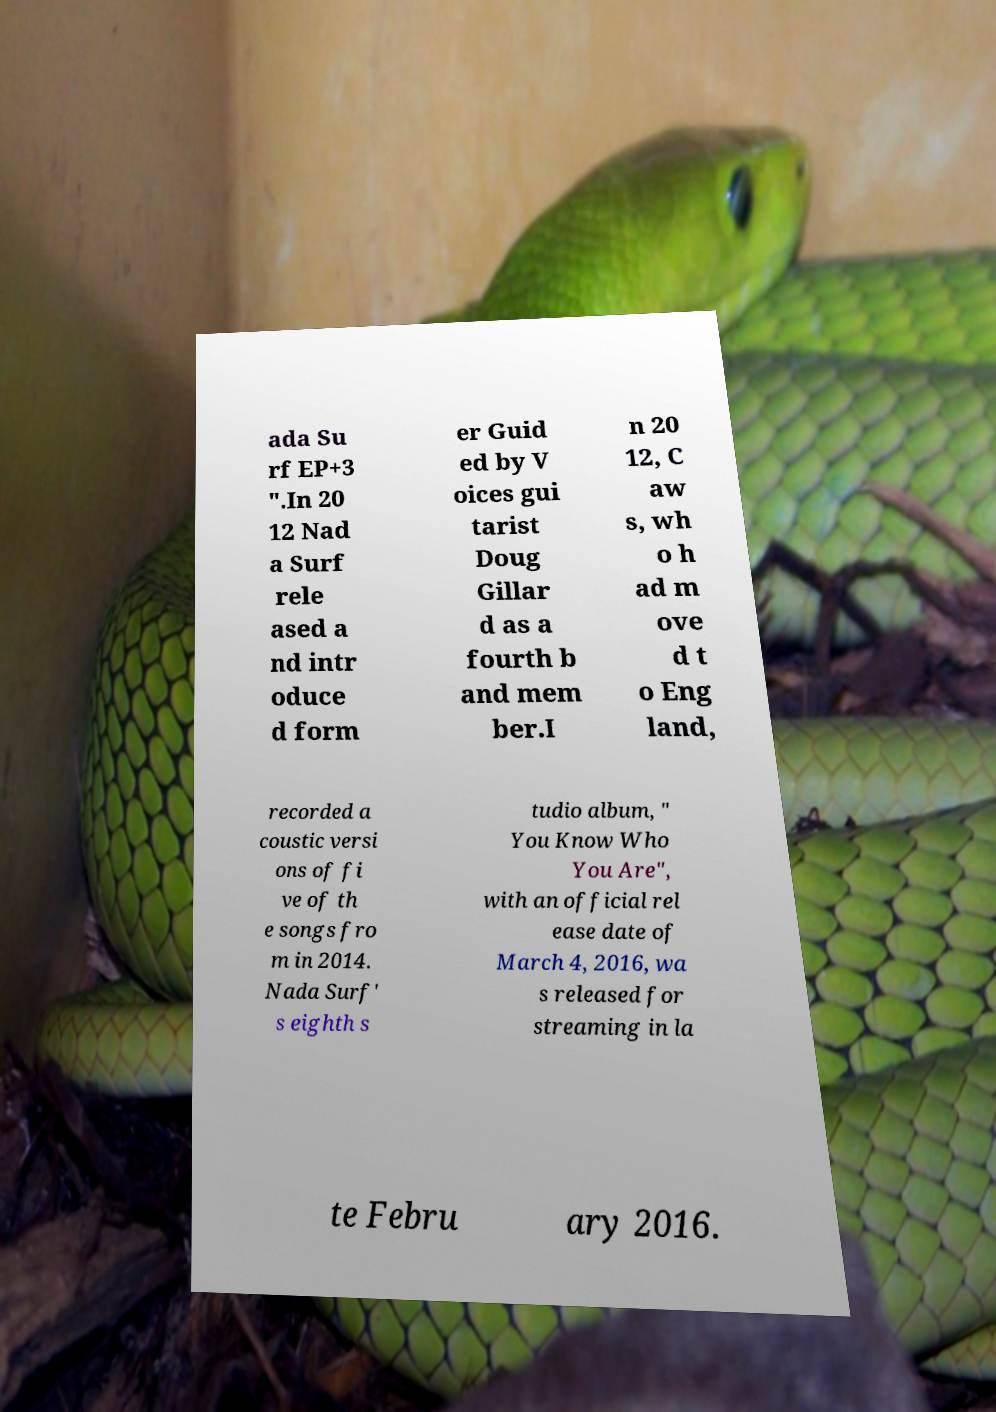There's text embedded in this image that I need extracted. Can you transcribe it verbatim? ada Su rf EP+3 ".In 20 12 Nad a Surf rele ased a nd intr oduce d form er Guid ed by V oices gui tarist Doug Gillar d as a fourth b and mem ber.I n 20 12, C aw s, wh o h ad m ove d t o Eng land, recorded a coustic versi ons of fi ve of th e songs fro m in 2014. Nada Surf' s eighth s tudio album, " You Know Who You Are", with an official rel ease date of March 4, 2016, wa s released for streaming in la te Febru ary 2016. 